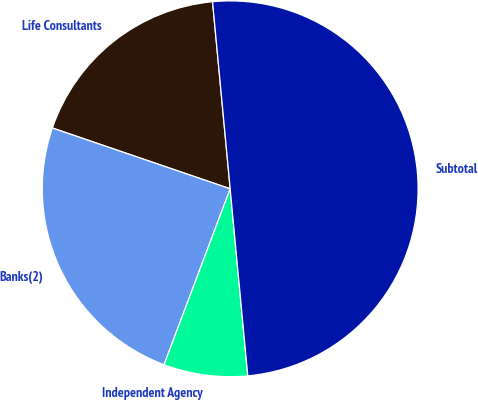Convert chart to OTSL. <chart><loc_0><loc_0><loc_500><loc_500><pie_chart><fcel>Life Consultants<fcel>Banks(2)<fcel>Independent Agency<fcel>Subtotal<nl><fcel>18.26%<fcel>24.52%<fcel>7.22%<fcel>50.0%<nl></chart> 